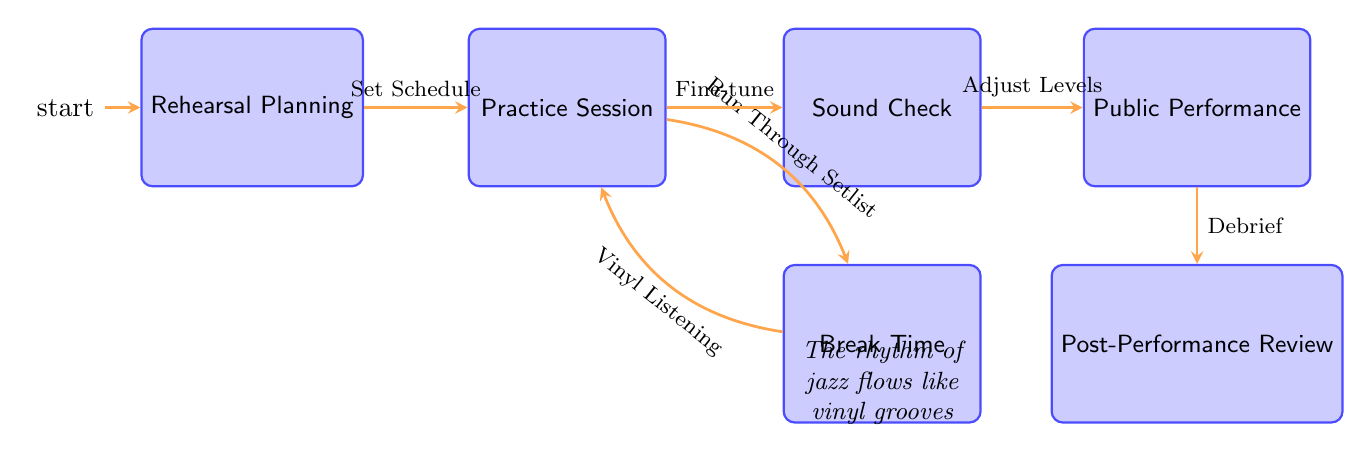What is the starting node in this diagram? The starting node is labeled "Rehearsal Planning," which is indicated as the initial state in the diagram.
Answer: Rehearsal Planning How many actions are listed for the "Sound Check" node? The "Sound Check" node has three actions associated with it: Setup Equipment, Adjust Levels, and Test Instruments, as explicitly stated above the node in the diagram.
Answer: 3 What is the action taken after the "Practice Session"? The next node in the flow, after "Practice Session," is "Sound Check," and so the action that leads to it is Fine-tune Arrangements.
Answer: Sound Check Which node comes after "Public Performance"? The node that comes immediately after "Public Performance" is the "Post-Performance Review," as shown by the directed edge extending from "Public Performance" to "Post-Performance Review."
Answer: Post-Performance Review What action is taken during "Break Time"? One of the actions listed during "Break Time" is a "Vinyl Listening Session," which highlights the significance of vinyl in experiencing music, especially in jazz.
Answer: Vinyl Listening Session What is the relationship between "Break Time" and "Practice Session"? The relationship is a feedback loop; after "Break Time," the flow returns to "Practice Session," showing that the band may continue to rehearse after the break.
Answer: Feedback Loop What is the total number of nodes in the diagram? By counting each labeled node in the diagram, there are a total of six distinct nodes involved in managing the jazz band through rehearsal to performance.
Answer: 6 Which action precedes the "Public Performance"? The action that precedes "Public Performance" is "Adjust Levels," linked through "Sound Check," indicating preparation before going on stage.
Answer: Adjust Levels 